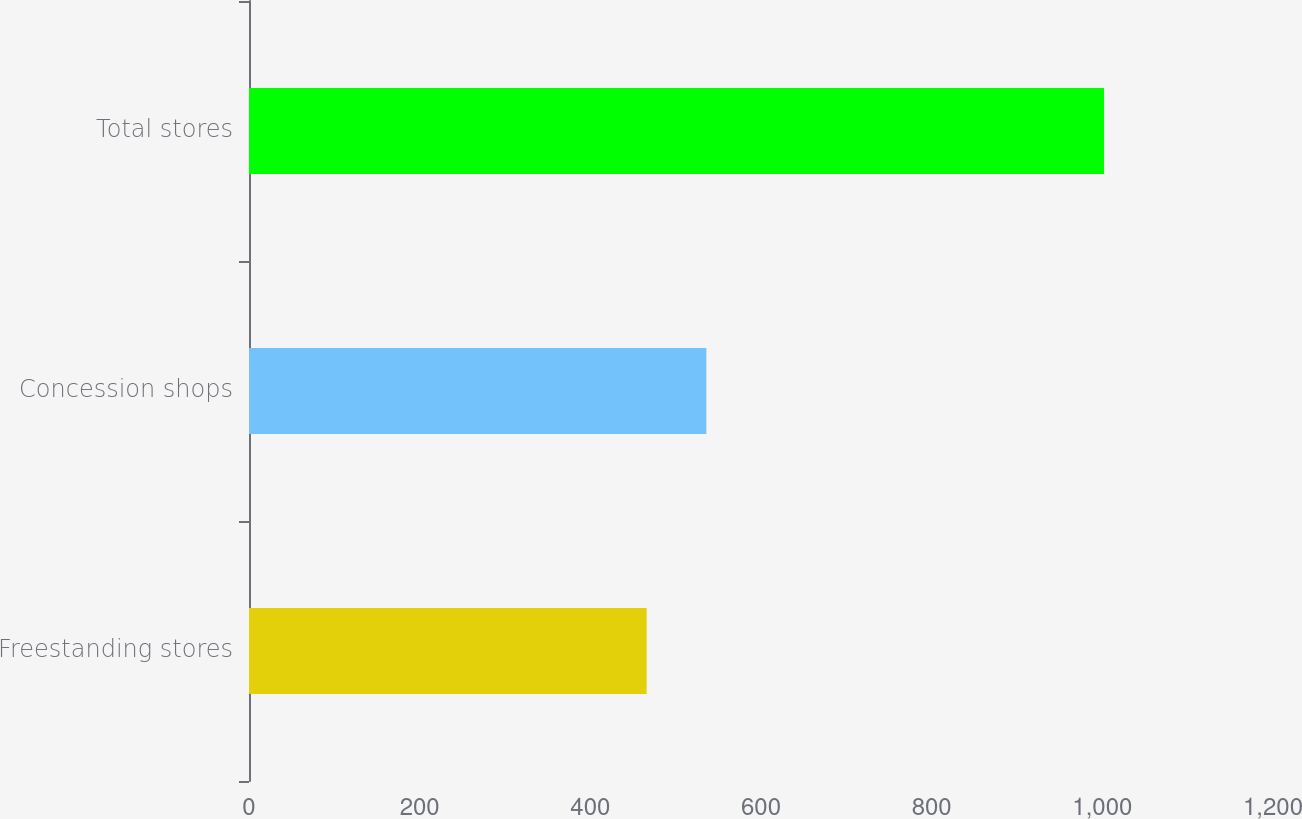Convert chart to OTSL. <chart><loc_0><loc_0><loc_500><loc_500><bar_chart><fcel>Freestanding stores<fcel>Concession shops<fcel>Total stores<nl><fcel>466<fcel>536<fcel>1002<nl></chart> 